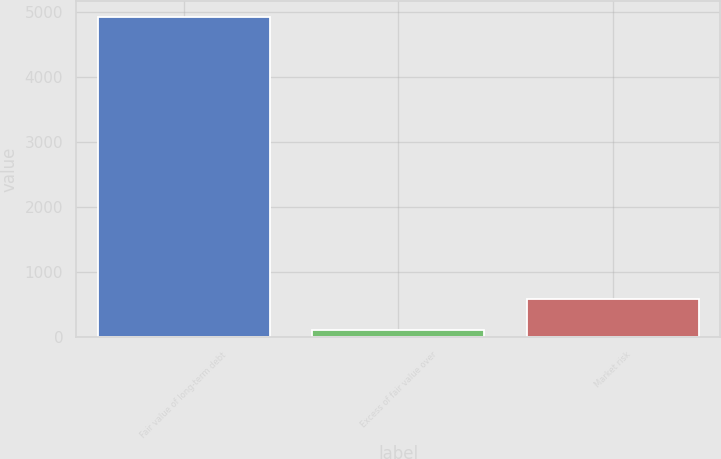Convert chart. <chart><loc_0><loc_0><loc_500><loc_500><bar_chart><fcel>Fair value of long-term debt<fcel>Excess of fair value over<fcel>Market risk<nl><fcel>4927<fcel>110<fcel>591.7<nl></chart> 